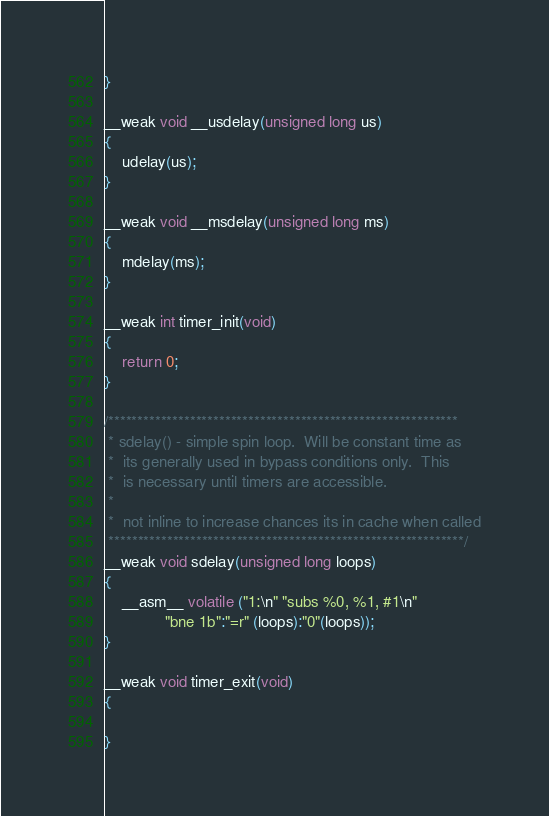<code> <loc_0><loc_0><loc_500><loc_500><_C_>}

__weak void __usdelay(unsigned long us)
{
	udelay(us);
}

__weak void __msdelay(unsigned long ms)
{
	mdelay(ms);
}

__weak int timer_init(void)
{
	return 0;
}

/************************************************************
 * sdelay() - simple spin loop.  Will be constant time as
 *  its generally used in bypass conditions only.  This
 *  is necessary until timers are accessible.
 *
 *  not inline to increase chances its in cache when called
 *************************************************************/
__weak void sdelay(unsigned long loops)
{
	__asm__ volatile ("1:\n" "subs %0, %1, #1\n"
			  "bne 1b":"=r" (loops):"0"(loops));
}

__weak void timer_exit(void)
{

}


</code> 